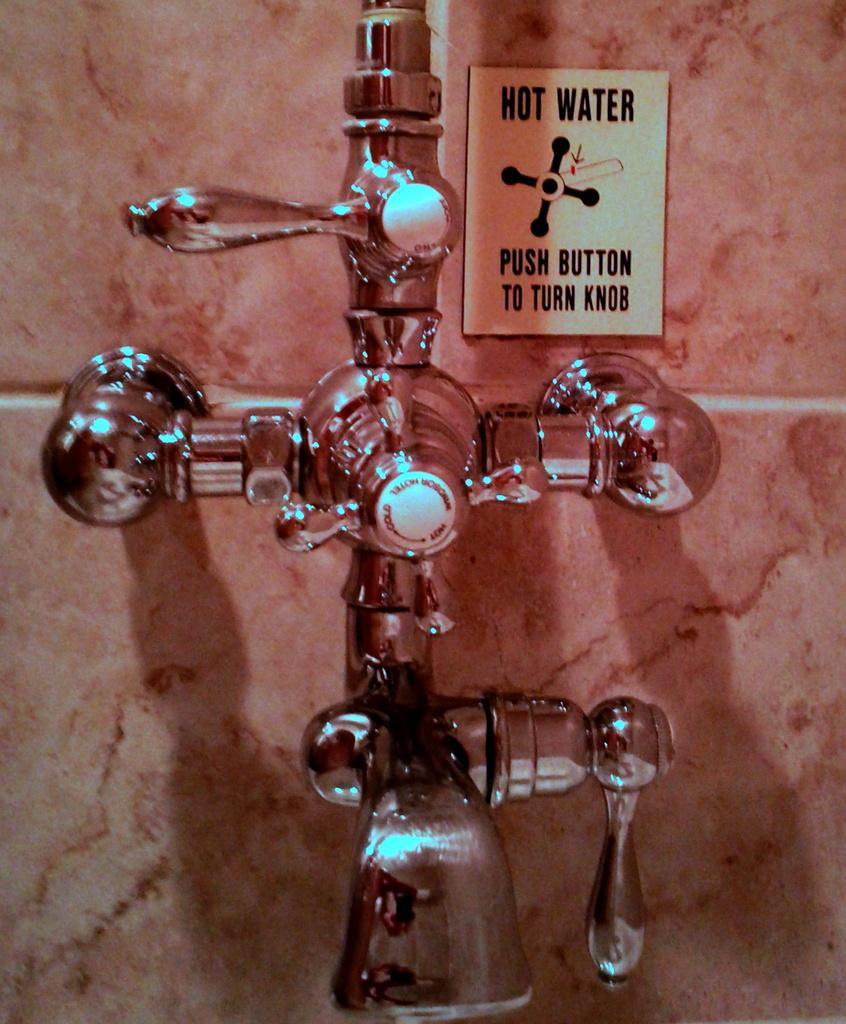How would you summarize this image in a sentence or two? In this image I can see the brown colored wall and to it I can see the metal taps and a board which is white and black in color. 